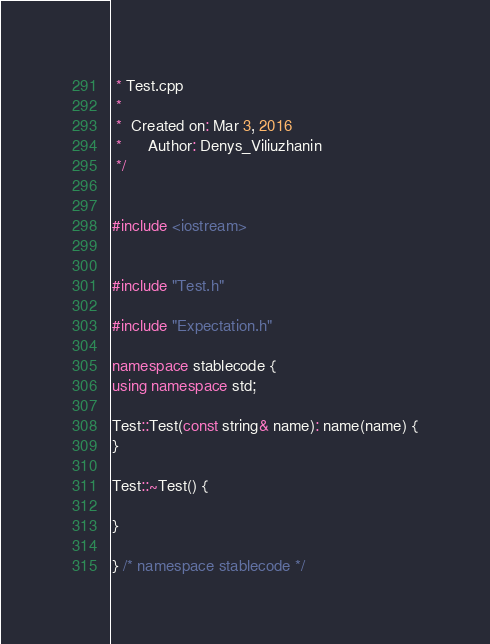<code> <loc_0><loc_0><loc_500><loc_500><_C++_> * Test.cpp
 *
 *  Created on: Mar 3, 2016
 *      Author: Denys_Viliuzhanin
 */


#include <iostream>


#include "Test.h"

#include "Expectation.h"

namespace stablecode {
using namespace std;

Test::Test(const string& name): name(name) {
}

Test::~Test() {

}

} /* namespace stablecode */

</code> 